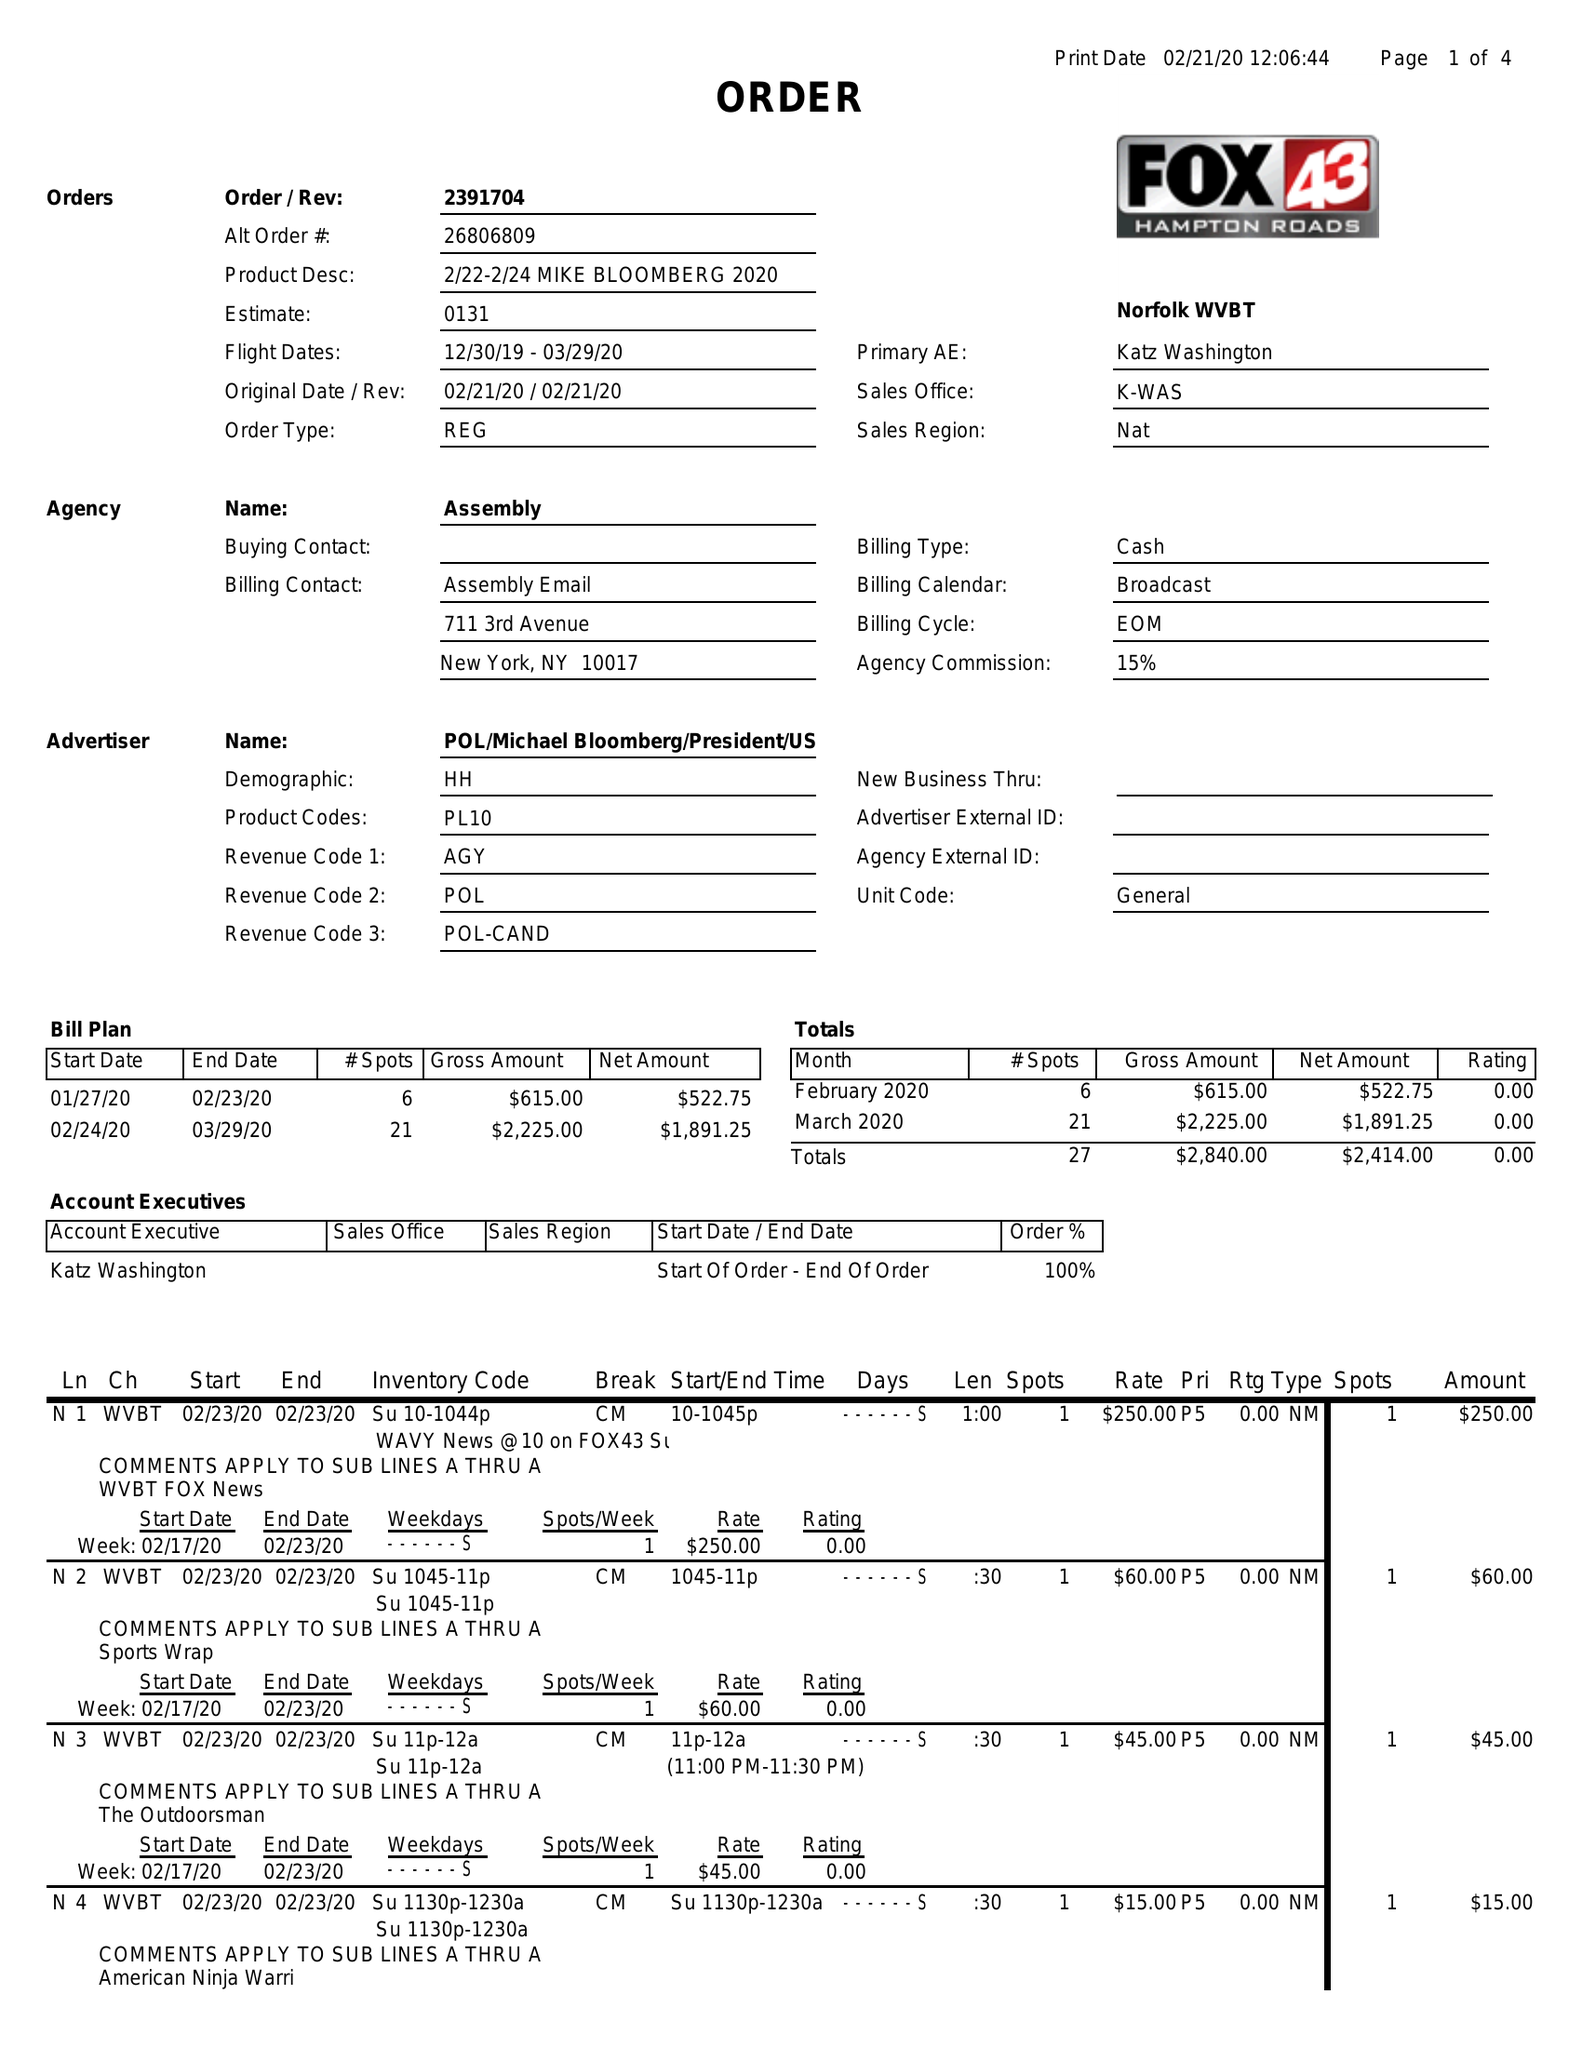What is the value for the flight_from?
Answer the question using a single word or phrase. 12/30/19 